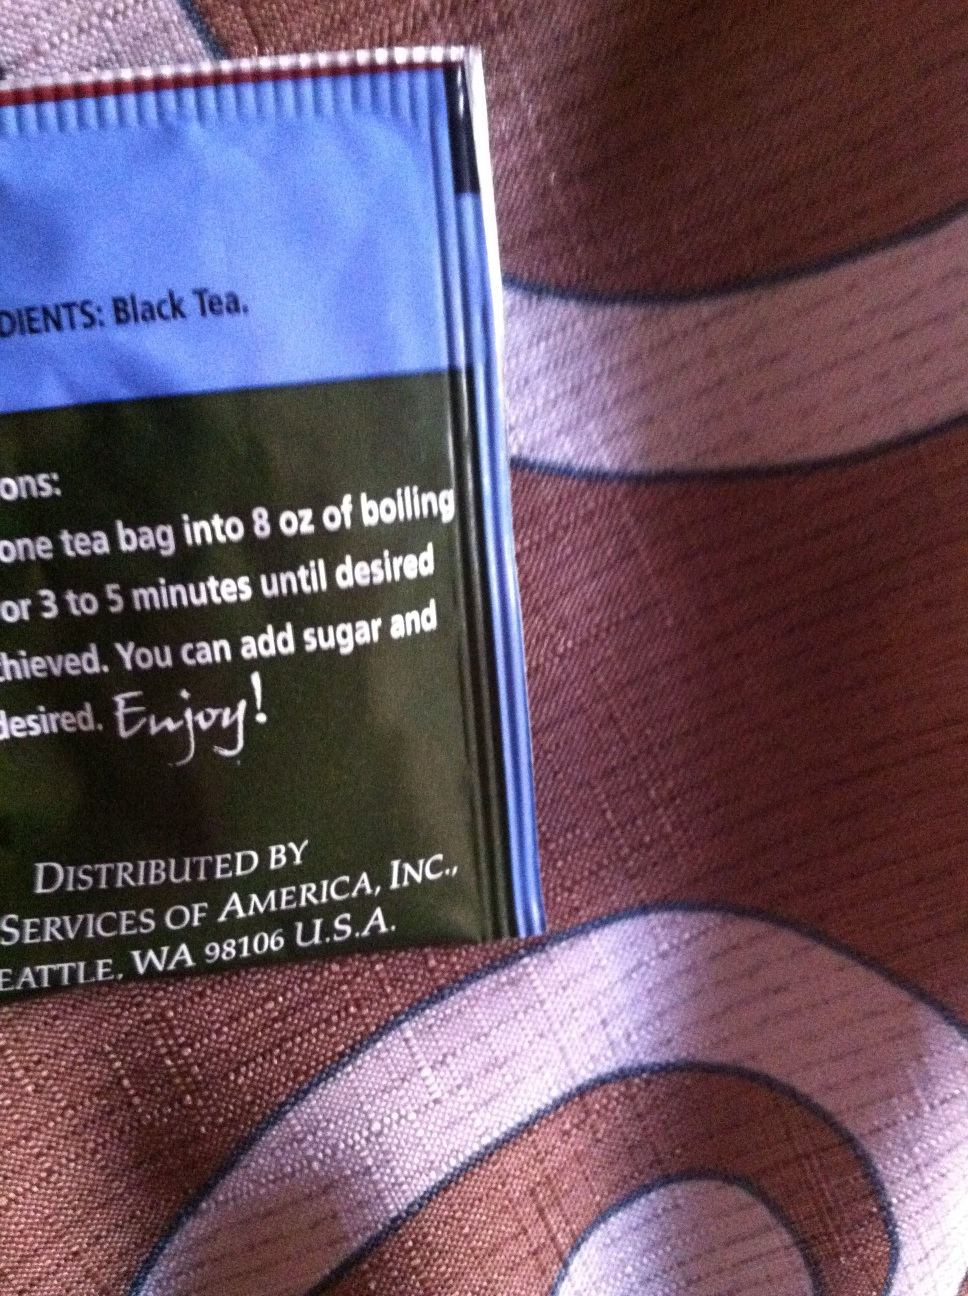Where is this tea distributed from? The black tea in the image is distributed by Services of America, Inc., located in Seattle, Washington, 98106, U.S.A. This makes it a product of a region known for its vibrant coffee and tea market. 